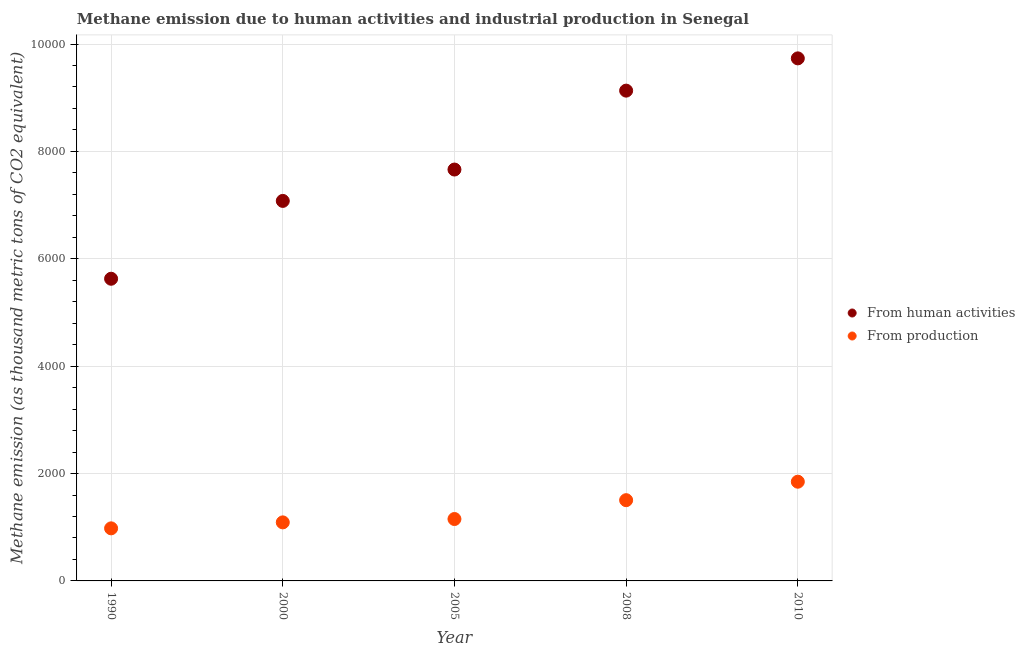Is the number of dotlines equal to the number of legend labels?
Your answer should be very brief. Yes. What is the amount of emissions from human activities in 1990?
Offer a very short reply. 5628.2. Across all years, what is the maximum amount of emissions generated from industries?
Your response must be concise. 1848. Across all years, what is the minimum amount of emissions generated from industries?
Provide a succinct answer. 979.3. In which year was the amount of emissions from human activities maximum?
Provide a succinct answer. 2010. In which year was the amount of emissions generated from industries minimum?
Your response must be concise. 1990. What is the total amount of emissions from human activities in the graph?
Offer a very short reply. 3.92e+04. What is the difference between the amount of emissions generated from industries in 2000 and that in 2008?
Provide a succinct answer. -413.6. What is the difference between the amount of emissions from human activities in 2010 and the amount of emissions generated from industries in 2008?
Your answer should be compact. 8228.9. What is the average amount of emissions from human activities per year?
Keep it short and to the point. 7846.7. In the year 2000, what is the difference between the amount of emissions from human activities and amount of emissions generated from industries?
Give a very brief answer. 5987.7. In how many years, is the amount of emissions from human activities greater than 400 thousand metric tons?
Provide a short and direct response. 5. What is the ratio of the amount of emissions generated from industries in 2000 to that in 2005?
Your answer should be compact. 0.95. Is the difference between the amount of emissions generated from industries in 1990 and 2005 greater than the difference between the amount of emissions from human activities in 1990 and 2005?
Your answer should be very brief. Yes. What is the difference between the highest and the second highest amount of emissions from human activities?
Keep it short and to the point. 601. What is the difference between the highest and the lowest amount of emissions from human activities?
Your answer should be very brief. 4104.7. In how many years, is the amount of emissions generated from industries greater than the average amount of emissions generated from industries taken over all years?
Your response must be concise. 2. Is the amount of emissions generated from industries strictly less than the amount of emissions from human activities over the years?
Offer a terse response. Yes. How many years are there in the graph?
Offer a very short reply. 5. Where does the legend appear in the graph?
Your answer should be compact. Center right. How many legend labels are there?
Offer a terse response. 2. What is the title of the graph?
Provide a short and direct response. Methane emission due to human activities and industrial production in Senegal. What is the label or title of the X-axis?
Your response must be concise. Year. What is the label or title of the Y-axis?
Offer a terse response. Methane emission (as thousand metric tons of CO2 equivalent). What is the Methane emission (as thousand metric tons of CO2 equivalent) of From human activities in 1990?
Make the answer very short. 5628.2. What is the Methane emission (as thousand metric tons of CO2 equivalent) in From production in 1990?
Your response must be concise. 979.3. What is the Methane emission (as thousand metric tons of CO2 equivalent) of From human activities in 2000?
Provide a succinct answer. 7078.1. What is the Methane emission (as thousand metric tons of CO2 equivalent) in From production in 2000?
Provide a short and direct response. 1090.4. What is the Methane emission (as thousand metric tons of CO2 equivalent) of From human activities in 2005?
Your answer should be very brief. 7662.4. What is the Methane emission (as thousand metric tons of CO2 equivalent) in From production in 2005?
Your response must be concise. 1153. What is the Methane emission (as thousand metric tons of CO2 equivalent) of From human activities in 2008?
Your answer should be very brief. 9131.9. What is the Methane emission (as thousand metric tons of CO2 equivalent) in From production in 2008?
Offer a terse response. 1504. What is the Methane emission (as thousand metric tons of CO2 equivalent) in From human activities in 2010?
Offer a terse response. 9732.9. What is the Methane emission (as thousand metric tons of CO2 equivalent) in From production in 2010?
Offer a terse response. 1848. Across all years, what is the maximum Methane emission (as thousand metric tons of CO2 equivalent) in From human activities?
Provide a succinct answer. 9732.9. Across all years, what is the maximum Methane emission (as thousand metric tons of CO2 equivalent) in From production?
Make the answer very short. 1848. Across all years, what is the minimum Methane emission (as thousand metric tons of CO2 equivalent) of From human activities?
Your answer should be compact. 5628.2. Across all years, what is the minimum Methane emission (as thousand metric tons of CO2 equivalent) in From production?
Keep it short and to the point. 979.3. What is the total Methane emission (as thousand metric tons of CO2 equivalent) of From human activities in the graph?
Keep it short and to the point. 3.92e+04. What is the total Methane emission (as thousand metric tons of CO2 equivalent) in From production in the graph?
Provide a short and direct response. 6574.7. What is the difference between the Methane emission (as thousand metric tons of CO2 equivalent) in From human activities in 1990 and that in 2000?
Your response must be concise. -1449.9. What is the difference between the Methane emission (as thousand metric tons of CO2 equivalent) of From production in 1990 and that in 2000?
Your response must be concise. -111.1. What is the difference between the Methane emission (as thousand metric tons of CO2 equivalent) in From human activities in 1990 and that in 2005?
Provide a short and direct response. -2034.2. What is the difference between the Methane emission (as thousand metric tons of CO2 equivalent) of From production in 1990 and that in 2005?
Offer a terse response. -173.7. What is the difference between the Methane emission (as thousand metric tons of CO2 equivalent) in From human activities in 1990 and that in 2008?
Make the answer very short. -3503.7. What is the difference between the Methane emission (as thousand metric tons of CO2 equivalent) in From production in 1990 and that in 2008?
Your response must be concise. -524.7. What is the difference between the Methane emission (as thousand metric tons of CO2 equivalent) in From human activities in 1990 and that in 2010?
Ensure brevity in your answer.  -4104.7. What is the difference between the Methane emission (as thousand metric tons of CO2 equivalent) of From production in 1990 and that in 2010?
Offer a terse response. -868.7. What is the difference between the Methane emission (as thousand metric tons of CO2 equivalent) of From human activities in 2000 and that in 2005?
Offer a terse response. -584.3. What is the difference between the Methane emission (as thousand metric tons of CO2 equivalent) of From production in 2000 and that in 2005?
Provide a short and direct response. -62.6. What is the difference between the Methane emission (as thousand metric tons of CO2 equivalent) of From human activities in 2000 and that in 2008?
Provide a short and direct response. -2053.8. What is the difference between the Methane emission (as thousand metric tons of CO2 equivalent) in From production in 2000 and that in 2008?
Offer a very short reply. -413.6. What is the difference between the Methane emission (as thousand metric tons of CO2 equivalent) in From human activities in 2000 and that in 2010?
Provide a short and direct response. -2654.8. What is the difference between the Methane emission (as thousand metric tons of CO2 equivalent) of From production in 2000 and that in 2010?
Your answer should be compact. -757.6. What is the difference between the Methane emission (as thousand metric tons of CO2 equivalent) in From human activities in 2005 and that in 2008?
Provide a succinct answer. -1469.5. What is the difference between the Methane emission (as thousand metric tons of CO2 equivalent) of From production in 2005 and that in 2008?
Offer a terse response. -351. What is the difference between the Methane emission (as thousand metric tons of CO2 equivalent) of From human activities in 2005 and that in 2010?
Provide a succinct answer. -2070.5. What is the difference between the Methane emission (as thousand metric tons of CO2 equivalent) in From production in 2005 and that in 2010?
Provide a succinct answer. -695. What is the difference between the Methane emission (as thousand metric tons of CO2 equivalent) of From human activities in 2008 and that in 2010?
Your answer should be compact. -601. What is the difference between the Methane emission (as thousand metric tons of CO2 equivalent) of From production in 2008 and that in 2010?
Make the answer very short. -344. What is the difference between the Methane emission (as thousand metric tons of CO2 equivalent) in From human activities in 1990 and the Methane emission (as thousand metric tons of CO2 equivalent) in From production in 2000?
Make the answer very short. 4537.8. What is the difference between the Methane emission (as thousand metric tons of CO2 equivalent) of From human activities in 1990 and the Methane emission (as thousand metric tons of CO2 equivalent) of From production in 2005?
Your answer should be very brief. 4475.2. What is the difference between the Methane emission (as thousand metric tons of CO2 equivalent) of From human activities in 1990 and the Methane emission (as thousand metric tons of CO2 equivalent) of From production in 2008?
Ensure brevity in your answer.  4124.2. What is the difference between the Methane emission (as thousand metric tons of CO2 equivalent) in From human activities in 1990 and the Methane emission (as thousand metric tons of CO2 equivalent) in From production in 2010?
Offer a terse response. 3780.2. What is the difference between the Methane emission (as thousand metric tons of CO2 equivalent) in From human activities in 2000 and the Methane emission (as thousand metric tons of CO2 equivalent) in From production in 2005?
Give a very brief answer. 5925.1. What is the difference between the Methane emission (as thousand metric tons of CO2 equivalent) of From human activities in 2000 and the Methane emission (as thousand metric tons of CO2 equivalent) of From production in 2008?
Keep it short and to the point. 5574.1. What is the difference between the Methane emission (as thousand metric tons of CO2 equivalent) of From human activities in 2000 and the Methane emission (as thousand metric tons of CO2 equivalent) of From production in 2010?
Your answer should be very brief. 5230.1. What is the difference between the Methane emission (as thousand metric tons of CO2 equivalent) in From human activities in 2005 and the Methane emission (as thousand metric tons of CO2 equivalent) in From production in 2008?
Provide a short and direct response. 6158.4. What is the difference between the Methane emission (as thousand metric tons of CO2 equivalent) in From human activities in 2005 and the Methane emission (as thousand metric tons of CO2 equivalent) in From production in 2010?
Provide a short and direct response. 5814.4. What is the difference between the Methane emission (as thousand metric tons of CO2 equivalent) in From human activities in 2008 and the Methane emission (as thousand metric tons of CO2 equivalent) in From production in 2010?
Offer a very short reply. 7283.9. What is the average Methane emission (as thousand metric tons of CO2 equivalent) in From human activities per year?
Ensure brevity in your answer.  7846.7. What is the average Methane emission (as thousand metric tons of CO2 equivalent) of From production per year?
Offer a very short reply. 1314.94. In the year 1990, what is the difference between the Methane emission (as thousand metric tons of CO2 equivalent) in From human activities and Methane emission (as thousand metric tons of CO2 equivalent) in From production?
Provide a short and direct response. 4648.9. In the year 2000, what is the difference between the Methane emission (as thousand metric tons of CO2 equivalent) of From human activities and Methane emission (as thousand metric tons of CO2 equivalent) of From production?
Your answer should be very brief. 5987.7. In the year 2005, what is the difference between the Methane emission (as thousand metric tons of CO2 equivalent) in From human activities and Methane emission (as thousand metric tons of CO2 equivalent) in From production?
Offer a very short reply. 6509.4. In the year 2008, what is the difference between the Methane emission (as thousand metric tons of CO2 equivalent) of From human activities and Methane emission (as thousand metric tons of CO2 equivalent) of From production?
Keep it short and to the point. 7627.9. In the year 2010, what is the difference between the Methane emission (as thousand metric tons of CO2 equivalent) in From human activities and Methane emission (as thousand metric tons of CO2 equivalent) in From production?
Ensure brevity in your answer.  7884.9. What is the ratio of the Methane emission (as thousand metric tons of CO2 equivalent) of From human activities in 1990 to that in 2000?
Keep it short and to the point. 0.8. What is the ratio of the Methane emission (as thousand metric tons of CO2 equivalent) in From production in 1990 to that in 2000?
Make the answer very short. 0.9. What is the ratio of the Methane emission (as thousand metric tons of CO2 equivalent) of From human activities in 1990 to that in 2005?
Offer a terse response. 0.73. What is the ratio of the Methane emission (as thousand metric tons of CO2 equivalent) of From production in 1990 to that in 2005?
Give a very brief answer. 0.85. What is the ratio of the Methane emission (as thousand metric tons of CO2 equivalent) of From human activities in 1990 to that in 2008?
Ensure brevity in your answer.  0.62. What is the ratio of the Methane emission (as thousand metric tons of CO2 equivalent) in From production in 1990 to that in 2008?
Your answer should be very brief. 0.65. What is the ratio of the Methane emission (as thousand metric tons of CO2 equivalent) of From human activities in 1990 to that in 2010?
Give a very brief answer. 0.58. What is the ratio of the Methane emission (as thousand metric tons of CO2 equivalent) in From production in 1990 to that in 2010?
Your response must be concise. 0.53. What is the ratio of the Methane emission (as thousand metric tons of CO2 equivalent) in From human activities in 2000 to that in 2005?
Provide a succinct answer. 0.92. What is the ratio of the Methane emission (as thousand metric tons of CO2 equivalent) of From production in 2000 to that in 2005?
Your answer should be compact. 0.95. What is the ratio of the Methane emission (as thousand metric tons of CO2 equivalent) in From human activities in 2000 to that in 2008?
Offer a very short reply. 0.78. What is the ratio of the Methane emission (as thousand metric tons of CO2 equivalent) of From production in 2000 to that in 2008?
Your answer should be compact. 0.72. What is the ratio of the Methane emission (as thousand metric tons of CO2 equivalent) of From human activities in 2000 to that in 2010?
Your answer should be compact. 0.73. What is the ratio of the Methane emission (as thousand metric tons of CO2 equivalent) in From production in 2000 to that in 2010?
Offer a terse response. 0.59. What is the ratio of the Methane emission (as thousand metric tons of CO2 equivalent) of From human activities in 2005 to that in 2008?
Give a very brief answer. 0.84. What is the ratio of the Methane emission (as thousand metric tons of CO2 equivalent) in From production in 2005 to that in 2008?
Your response must be concise. 0.77. What is the ratio of the Methane emission (as thousand metric tons of CO2 equivalent) of From human activities in 2005 to that in 2010?
Make the answer very short. 0.79. What is the ratio of the Methane emission (as thousand metric tons of CO2 equivalent) in From production in 2005 to that in 2010?
Offer a terse response. 0.62. What is the ratio of the Methane emission (as thousand metric tons of CO2 equivalent) of From human activities in 2008 to that in 2010?
Provide a succinct answer. 0.94. What is the ratio of the Methane emission (as thousand metric tons of CO2 equivalent) of From production in 2008 to that in 2010?
Keep it short and to the point. 0.81. What is the difference between the highest and the second highest Methane emission (as thousand metric tons of CO2 equivalent) of From human activities?
Provide a short and direct response. 601. What is the difference between the highest and the second highest Methane emission (as thousand metric tons of CO2 equivalent) in From production?
Your response must be concise. 344. What is the difference between the highest and the lowest Methane emission (as thousand metric tons of CO2 equivalent) of From human activities?
Provide a short and direct response. 4104.7. What is the difference between the highest and the lowest Methane emission (as thousand metric tons of CO2 equivalent) in From production?
Your answer should be very brief. 868.7. 